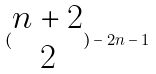<formula> <loc_0><loc_0><loc_500><loc_500>( \begin{matrix} n + 2 \\ 2 \end{matrix} ) - 2 n - 1</formula> 